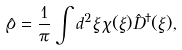<formula> <loc_0><loc_0><loc_500><loc_500>\hat { \varrho } = \frac { 1 } { \pi } \int d ^ { 2 } \xi \, \chi ( \xi ) \hat { D } ^ { \dagger } ( \xi ) ,</formula> 